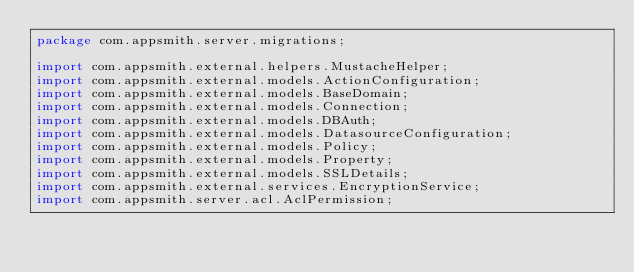Convert code to text. <code><loc_0><loc_0><loc_500><loc_500><_Java_>package com.appsmith.server.migrations;

import com.appsmith.external.helpers.MustacheHelper;
import com.appsmith.external.models.ActionConfiguration;
import com.appsmith.external.models.BaseDomain;
import com.appsmith.external.models.Connection;
import com.appsmith.external.models.DBAuth;
import com.appsmith.external.models.DatasourceConfiguration;
import com.appsmith.external.models.Policy;
import com.appsmith.external.models.Property;
import com.appsmith.external.models.SSLDetails;
import com.appsmith.external.services.EncryptionService;
import com.appsmith.server.acl.AclPermission;</code> 